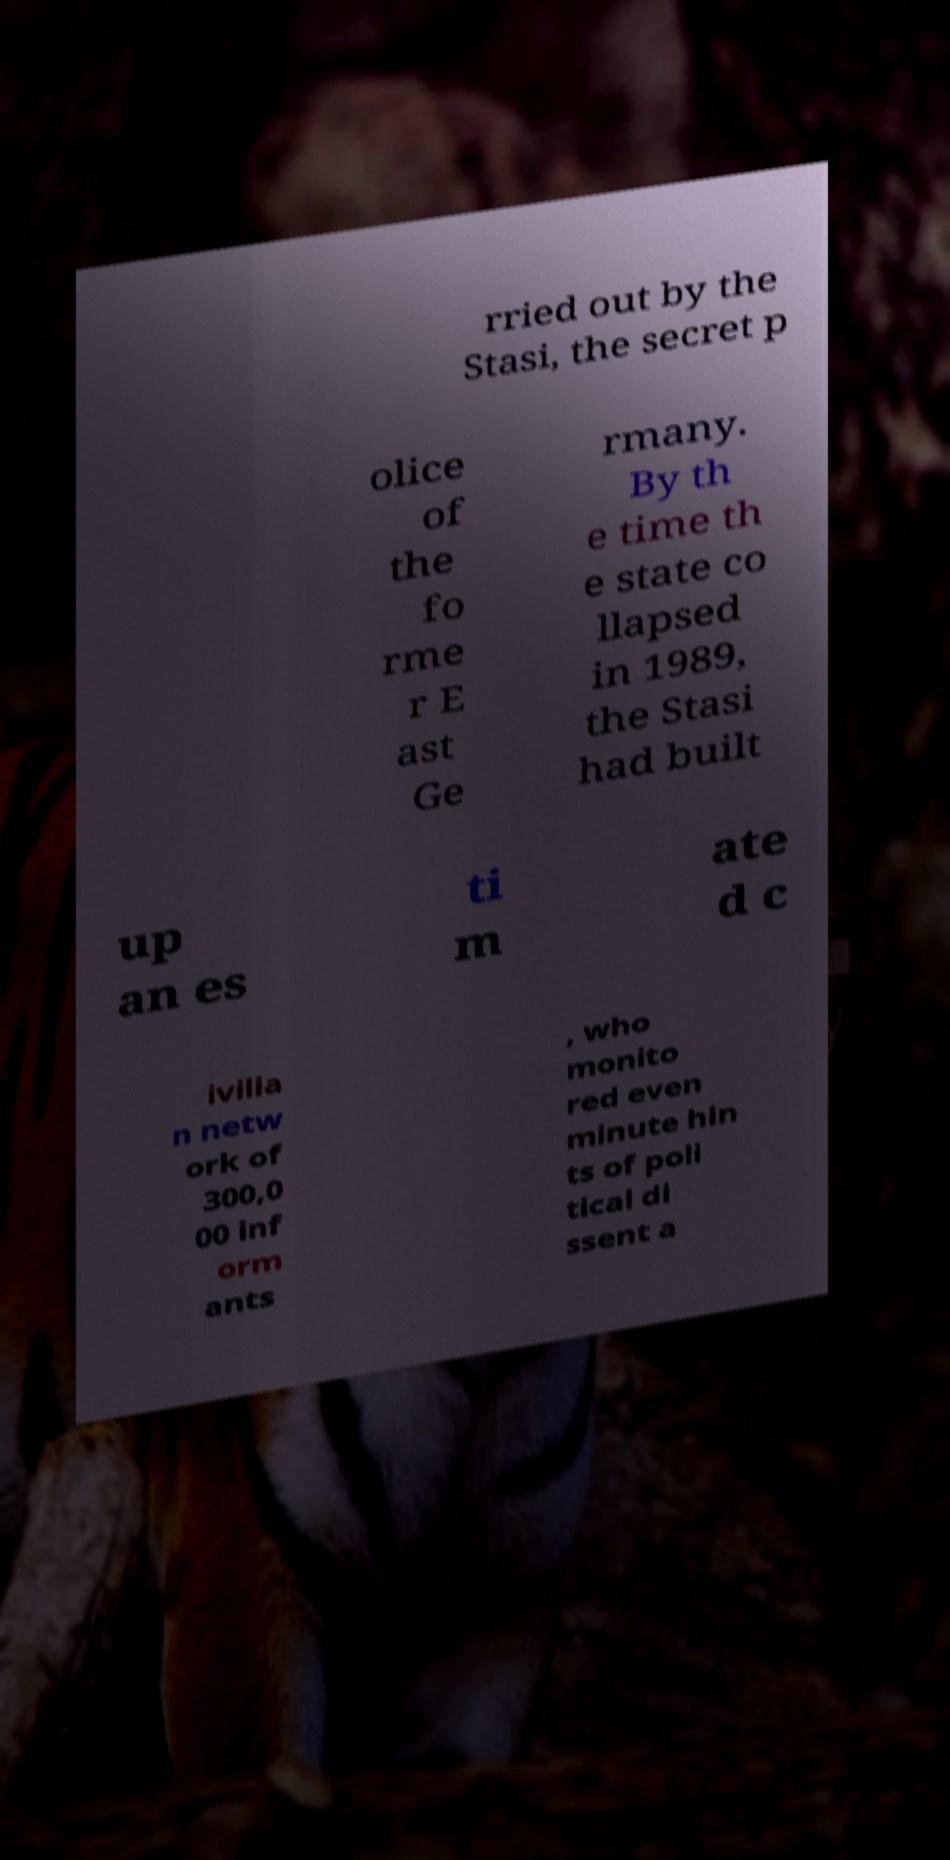I need the written content from this picture converted into text. Can you do that? rried out by the Stasi, the secret p olice of the fo rme r E ast Ge rmany. By th e time th e state co llapsed in 1989, the Stasi had built up an es ti m ate d c ivilia n netw ork of 300,0 00 inf orm ants , who monito red even minute hin ts of poli tical di ssent a 